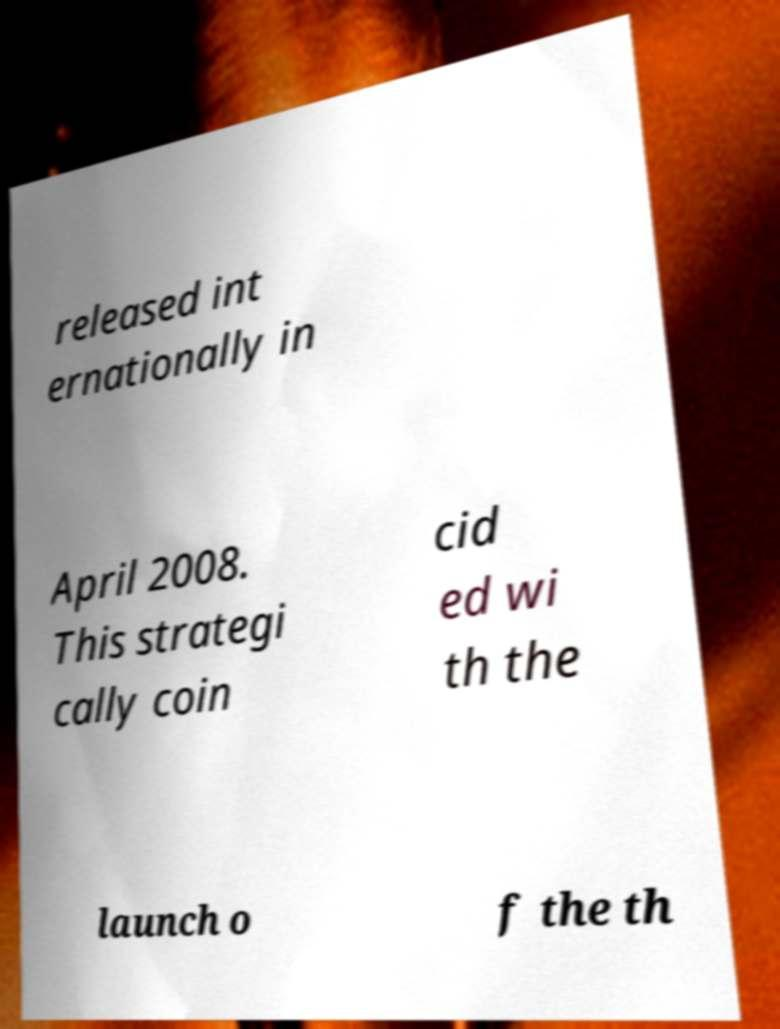Could you assist in decoding the text presented in this image and type it out clearly? released int ernationally in April 2008. This strategi cally coin cid ed wi th the launch o f the th 